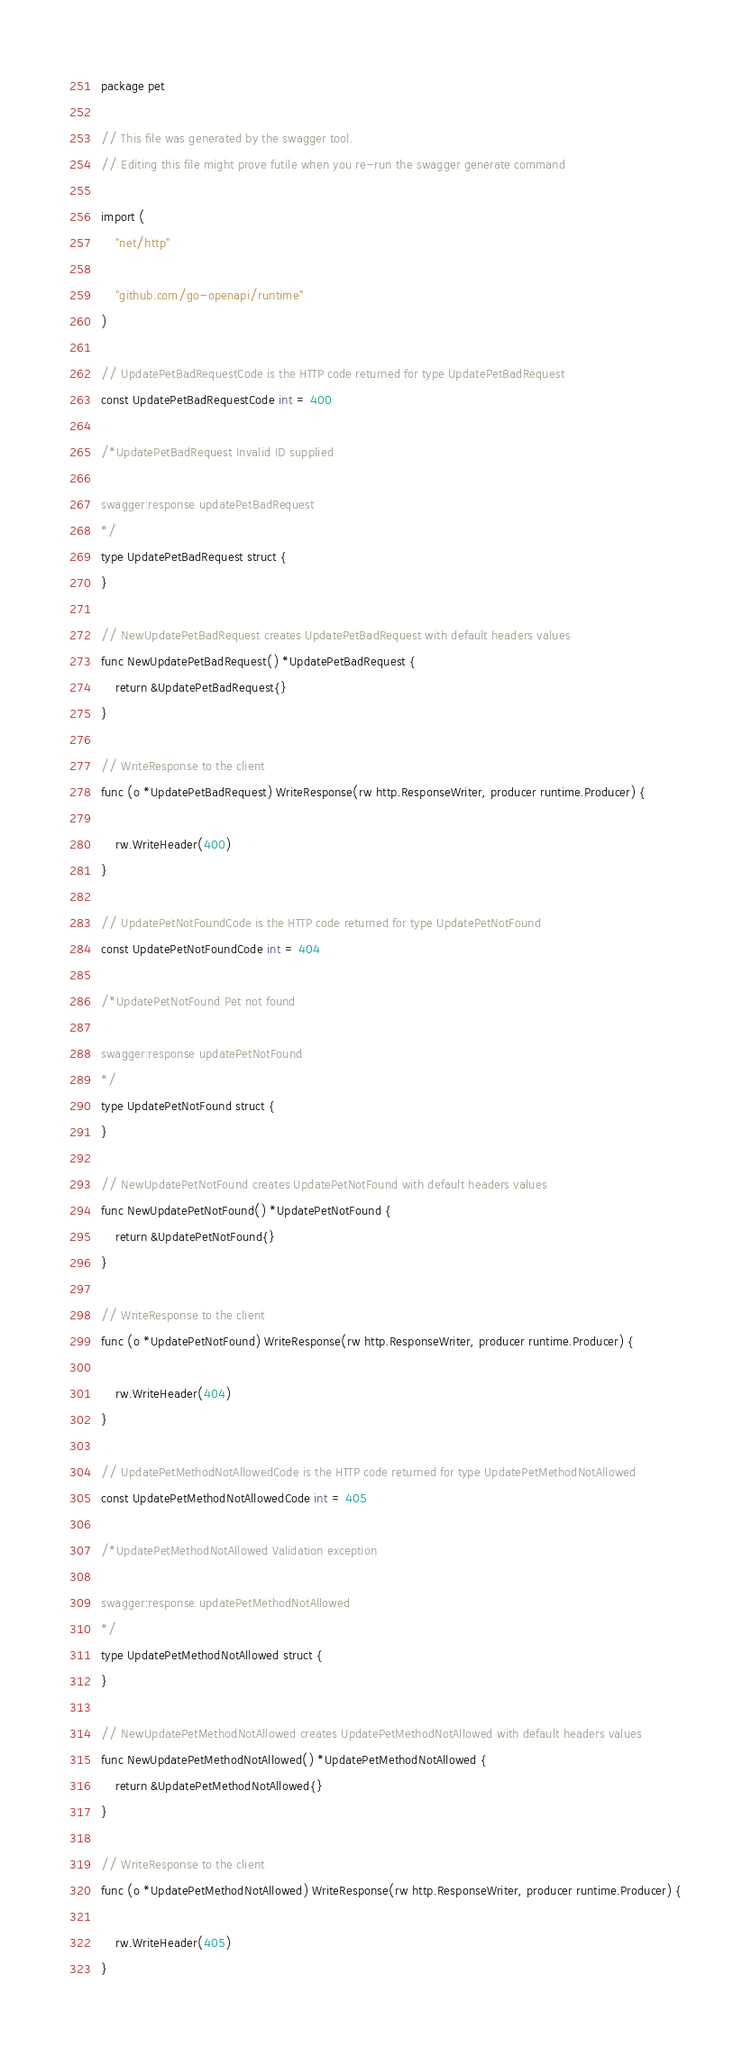Convert code to text. <code><loc_0><loc_0><loc_500><loc_500><_Go_>package pet

// This file was generated by the swagger tool.
// Editing this file might prove futile when you re-run the swagger generate command

import (
	"net/http"

	"github.com/go-openapi/runtime"
)

// UpdatePetBadRequestCode is the HTTP code returned for type UpdatePetBadRequest
const UpdatePetBadRequestCode int = 400

/*UpdatePetBadRequest Invalid ID supplied

swagger:response updatePetBadRequest
*/
type UpdatePetBadRequest struct {
}

// NewUpdatePetBadRequest creates UpdatePetBadRequest with default headers values
func NewUpdatePetBadRequest() *UpdatePetBadRequest {
	return &UpdatePetBadRequest{}
}

// WriteResponse to the client
func (o *UpdatePetBadRequest) WriteResponse(rw http.ResponseWriter, producer runtime.Producer) {

	rw.WriteHeader(400)
}

// UpdatePetNotFoundCode is the HTTP code returned for type UpdatePetNotFound
const UpdatePetNotFoundCode int = 404

/*UpdatePetNotFound Pet not found

swagger:response updatePetNotFound
*/
type UpdatePetNotFound struct {
}

// NewUpdatePetNotFound creates UpdatePetNotFound with default headers values
func NewUpdatePetNotFound() *UpdatePetNotFound {
	return &UpdatePetNotFound{}
}

// WriteResponse to the client
func (o *UpdatePetNotFound) WriteResponse(rw http.ResponseWriter, producer runtime.Producer) {

	rw.WriteHeader(404)
}

// UpdatePetMethodNotAllowedCode is the HTTP code returned for type UpdatePetMethodNotAllowed
const UpdatePetMethodNotAllowedCode int = 405

/*UpdatePetMethodNotAllowed Validation exception

swagger:response updatePetMethodNotAllowed
*/
type UpdatePetMethodNotAllowed struct {
}

// NewUpdatePetMethodNotAllowed creates UpdatePetMethodNotAllowed with default headers values
func NewUpdatePetMethodNotAllowed() *UpdatePetMethodNotAllowed {
	return &UpdatePetMethodNotAllowed{}
}

// WriteResponse to the client
func (o *UpdatePetMethodNotAllowed) WriteResponse(rw http.ResponseWriter, producer runtime.Producer) {

	rw.WriteHeader(405)
}
</code> 